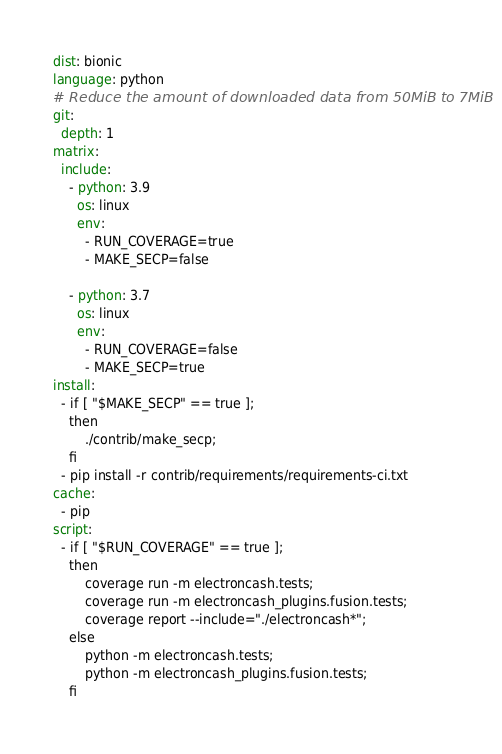<code> <loc_0><loc_0><loc_500><loc_500><_YAML_>
dist: bionic
language: python
# Reduce the amount of downloaded data from 50MiB to 7MiB
git:
  depth: 1
matrix:
  include:
    - python: 3.9
      os: linux
      env:
        - RUN_COVERAGE=true
        - MAKE_SECP=false

    - python: 3.7
      os: linux
      env:
        - RUN_COVERAGE=false
        - MAKE_SECP=true
install:
  - if [ "$MAKE_SECP" == true ];
    then
        ./contrib/make_secp;
    fi
  - pip install -r contrib/requirements/requirements-ci.txt
cache:
  - pip
script:
  - if [ "$RUN_COVERAGE" == true ];
    then
        coverage run -m electroncash.tests;
        coverage run -m electroncash_plugins.fusion.tests;
        coverage report --include="./electroncash*";
    else
        python -m electroncash.tests;
        python -m electroncash_plugins.fusion.tests;
    fi
</code> 